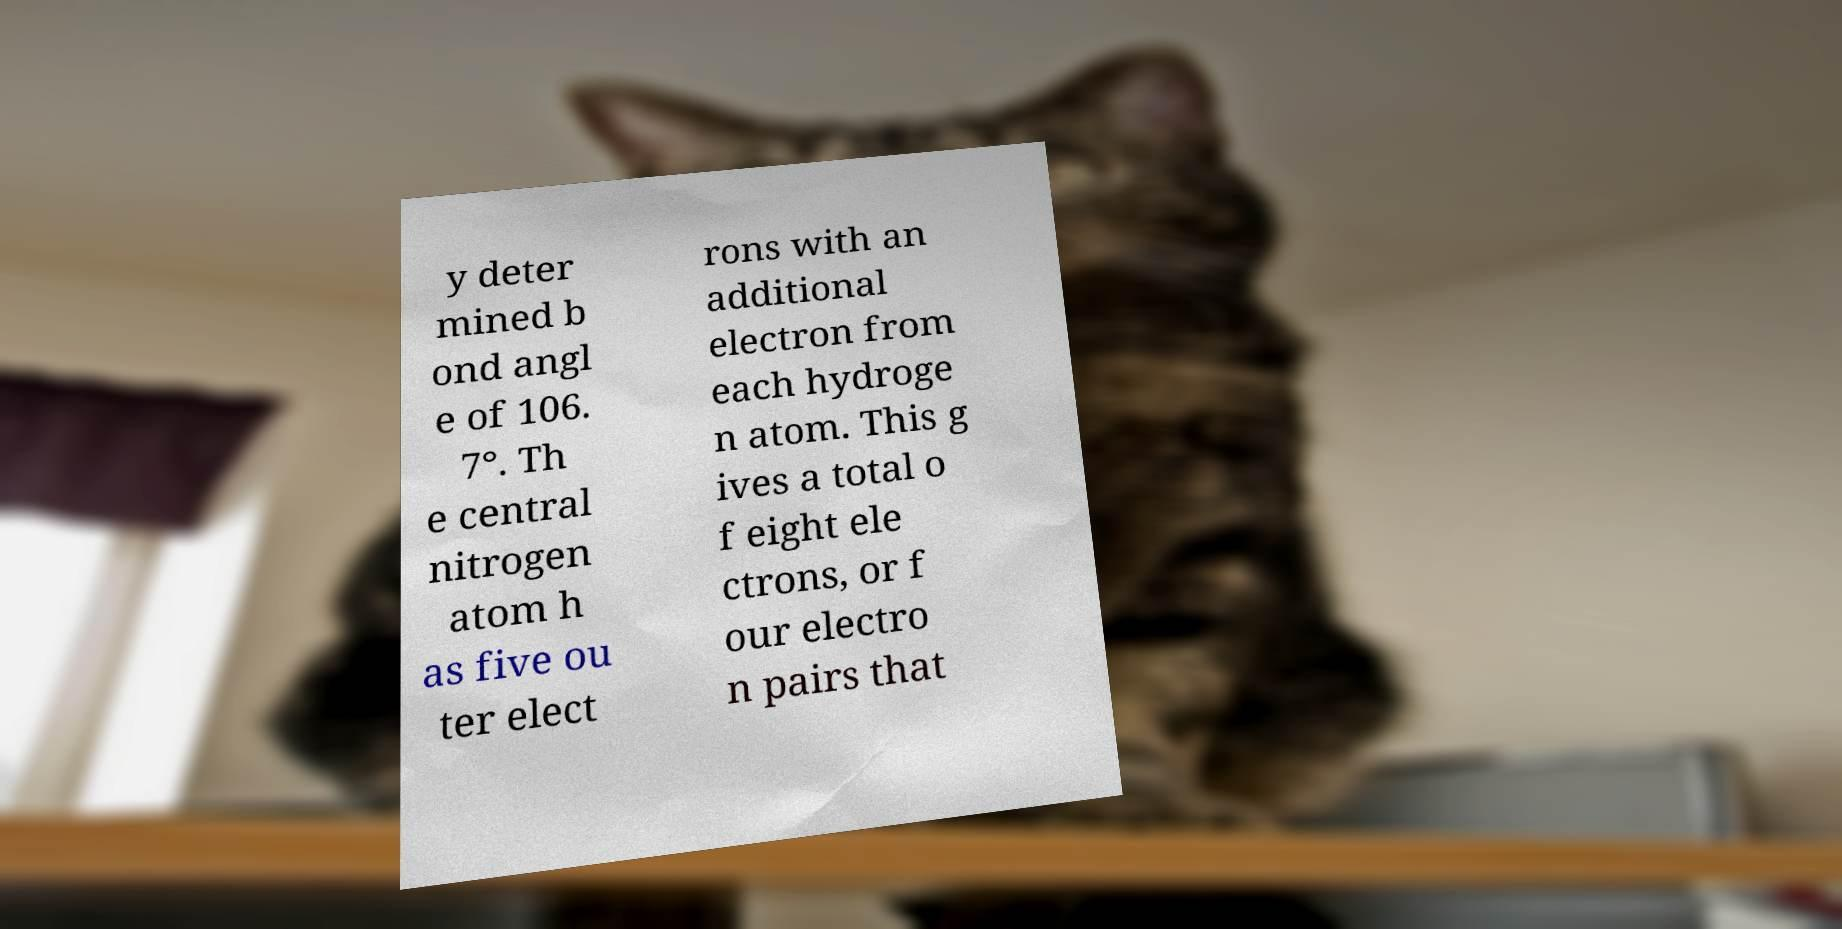Please identify and transcribe the text found in this image. y deter mined b ond angl e of 106. 7°. Th e central nitrogen atom h as five ou ter elect rons with an additional electron from each hydroge n atom. This g ives a total o f eight ele ctrons, or f our electro n pairs that 